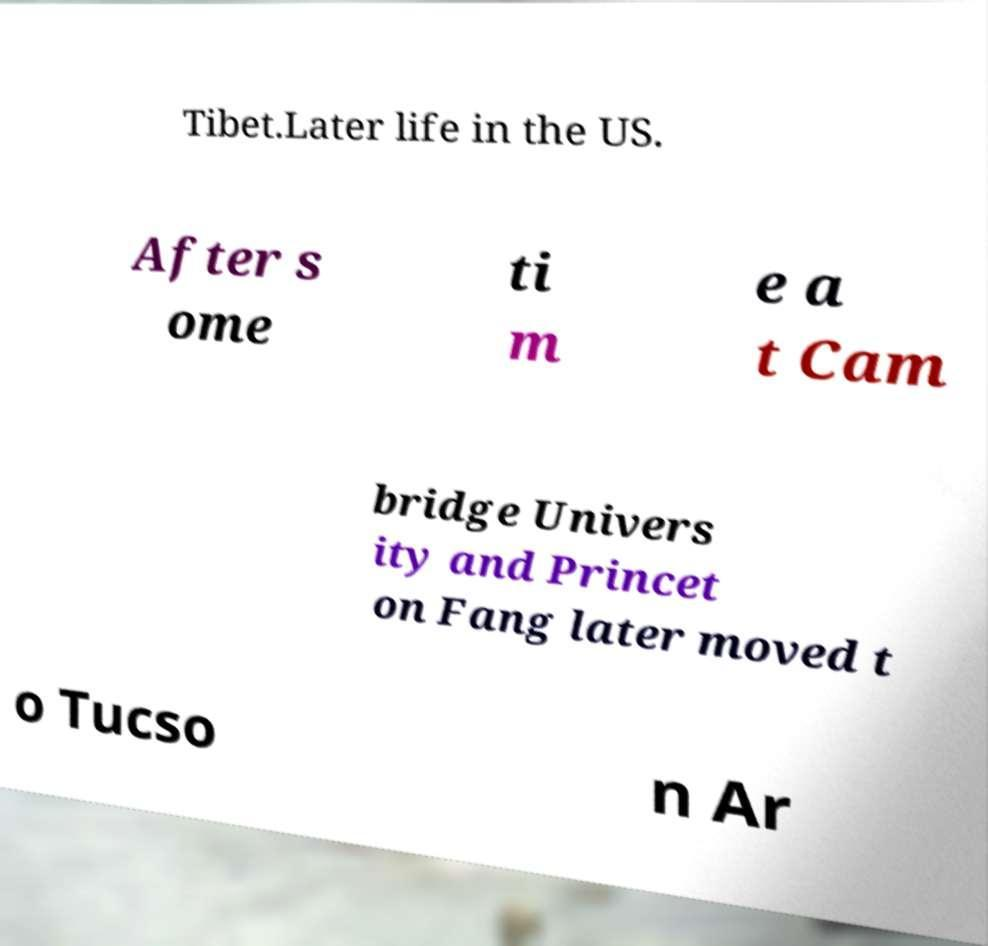Please read and relay the text visible in this image. What does it say? Tibet.Later life in the US. After s ome ti m e a t Cam bridge Univers ity and Princet on Fang later moved t o Tucso n Ar 